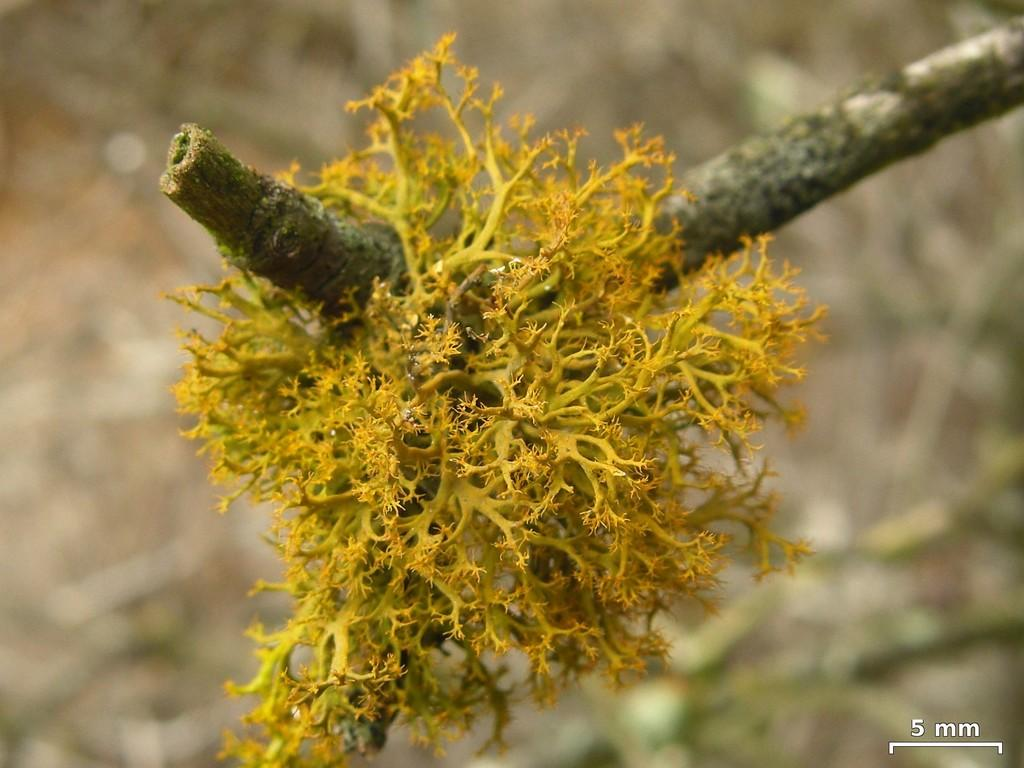What is the main subject in the center of the image? There is a plant in the center of the image. Where can text be found in the image? The text is located at the bottom right side of the image. How would you describe the background of the image? The background of the image is blurred. What does the queen say in the scene depicted in the image? There is no scene or queen present in the image; it features a plant and text on a blurred background. 